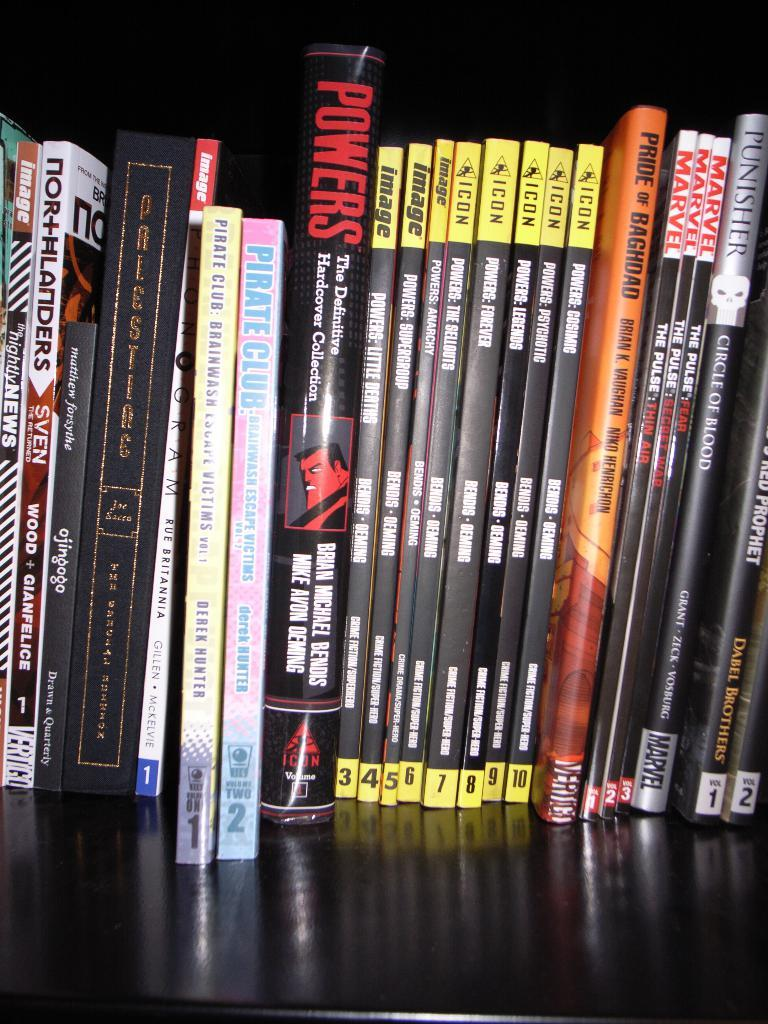<image>
Describe the image concisely. A line of books on a shelf and one is about the pride of Baghdad. 